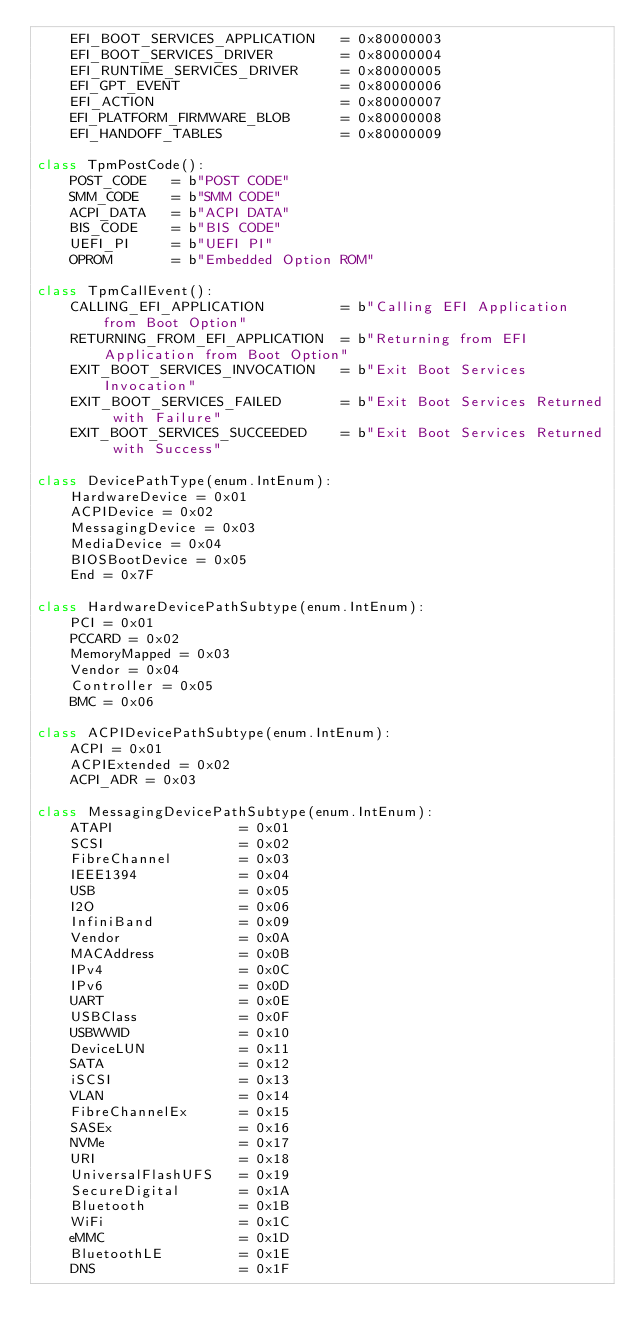<code> <loc_0><loc_0><loc_500><loc_500><_Python_>    EFI_BOOT_SERVICES_APPLICATION   = 0x80000003
    EFI_BOOT_SERVICES_DRIVER        = 0x80000004
    EFI_RUNTIME_SERVICES_DRIVER     = 0x80000005
    EFI_GPT_EVENT                   = 0x80000006
    EFI_ACTION                      = 0x80000007
    EFI_PLATFORM_FIRMWARE_BLOB      = 0x80000008
    EFI_HANDOFF_TABLES              = 0x80000009

class TpmPostCode():
    POST_CODE   = b"POST CODE"
    SMM_CODE    = b"SMM CODE"
    ACPI_DATA   = b"ACPI DATA"
    BIS_CODE    = b"BIS CODE"
    UEFI_PI     = b"UEFI PI"
    OPROM       = b"Embedded Option ROM"

class TpmCallEvent():
    CALLING_EFI_APPLICATION         = b"Calling EFI Application from Boot Option"
    RETURNING_FROM_EFI_APPLICATION  = b"Returning from EFI Application from Boot Option"
    EXIT_BOOT_SERVICES_INVOCATION   = b"Exit Boot Services Invocation"
    EXIT_BOOT_SERVICES_FAILED       = b"Exit Boot Services Returned with Failure"
    EXIT_BOOT_SERVICES_SUCCEEDED    = b"Exit Boot Services Returned with Success"

class DevicePathType(enum.IntEnum):
    HardwareDevice = 0x01
    ACPIDevice = 0x02
    MessagingDevice = 0x03
    MediaDevice = 0x04
    BIOSBootDevice = 0x05
    End = 0x7F

class HardwareDevicePathSubtype(enum.IntEnum):
    PCI = 0x01
    PCCARD = 0x02
    MemoryMapped = 0x03
    Vendor = 0x04
    Controller = 0x05
    BMC = 0x06

class ACPIDevicePathSubtype(enum.IntEnum):
    ACPI = 0x01
    ACPIExtended = 0x02
    ACPI_ADR = 0x03

class MessagingDevicePathSubtype(enum.IntEnum):
    ATAPI               = 0x01
    SCSI                = 0x02
    FibreChannel        = 0x03
    IEEE1394            = 0x04
    USB                 = 0x05
    I2O                 = 0x06
    InfiniBand          = 0x09
    Vendor              = 0x0A
    MACAddress          = 0x0B
    IPv4                = 0x0C
    IPv6                = 0x0D
    UART                = 0x0E
    USBClass            = 0x0F
    USBWWID             = 0x10
    DeviceLUN           = 0x11
    SATA                = 0x12
    iSCSI               = 0x13
    VLAN                = 0x14
    FibreChannelEx      = 0x15
    SASEx               = 0x16
    NVMe                = 0x17
    URI                 = 0x18
    UniversalFlashUFS   = 0x19
    SecureDigital       = 0x1A
    Bluetooth           = 0x1B
    WiFi                = 0x1C
    eMMC                = 0x1D
    BluetoothLE         = 0x1E
    DNS                 = 0x1F
</code> 